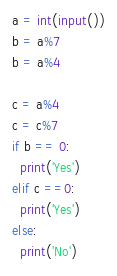Convert code to text. <code><loc_0><loc_0><loc_500><loc_500><_Python_>a = int(input())
b = a%7
b = a%4

c = a%4
c = c%7
if b == 0:
  print('Yes')
elif c ==0:
  print('Yes')
else:
  print('No')</code> 